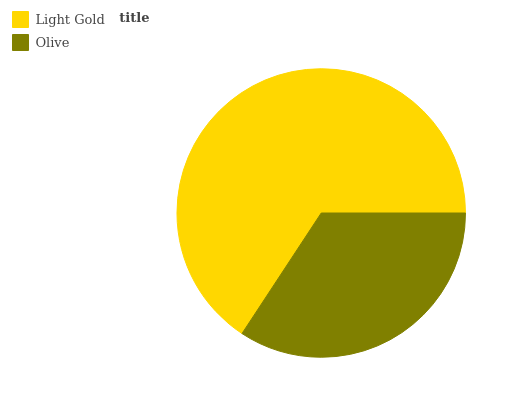Is Olive the minimum?
Answer yes or no. Yes. Is Light Gold the maximum?
Answer yes or no. Yes. Is Olive the maximum?
Answer yes or no. No. Is Light Gold greater than Olive?
Answer yes or no. Yes. Is Olive less than Light Gold?
Answer yes or no. Yes. Is Olive greater than Light Gold?
Answer yes or no. No. Is Light Gold less than Olive?
Answer yes or no. No. Is Light Gold the high median?
Answer yes or no. Yes. Is Olive the low median?
Answer yes or no. Yes. Is Olive the high median?
Answer yes or no. No. Is Light Gold the low median?
Answer yes or no. No. 